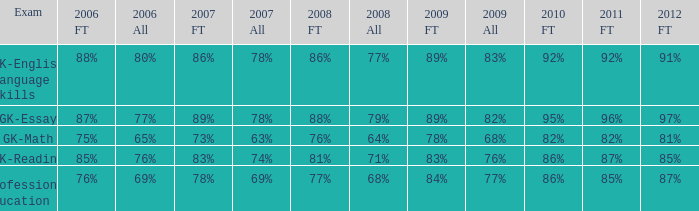What is the percentage for 2008 First time when in 2006 it was 85%? 81%. 